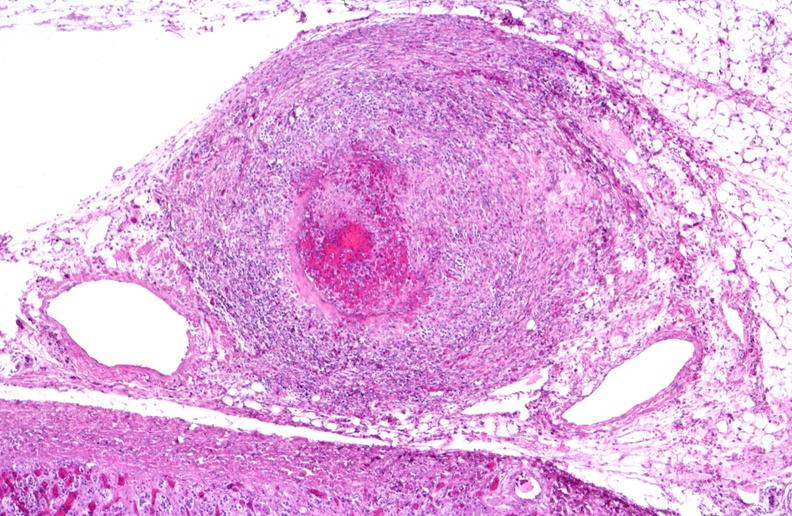what does this image show?
Answer the question using a single word or phrase. Polyarteritis nodosa 